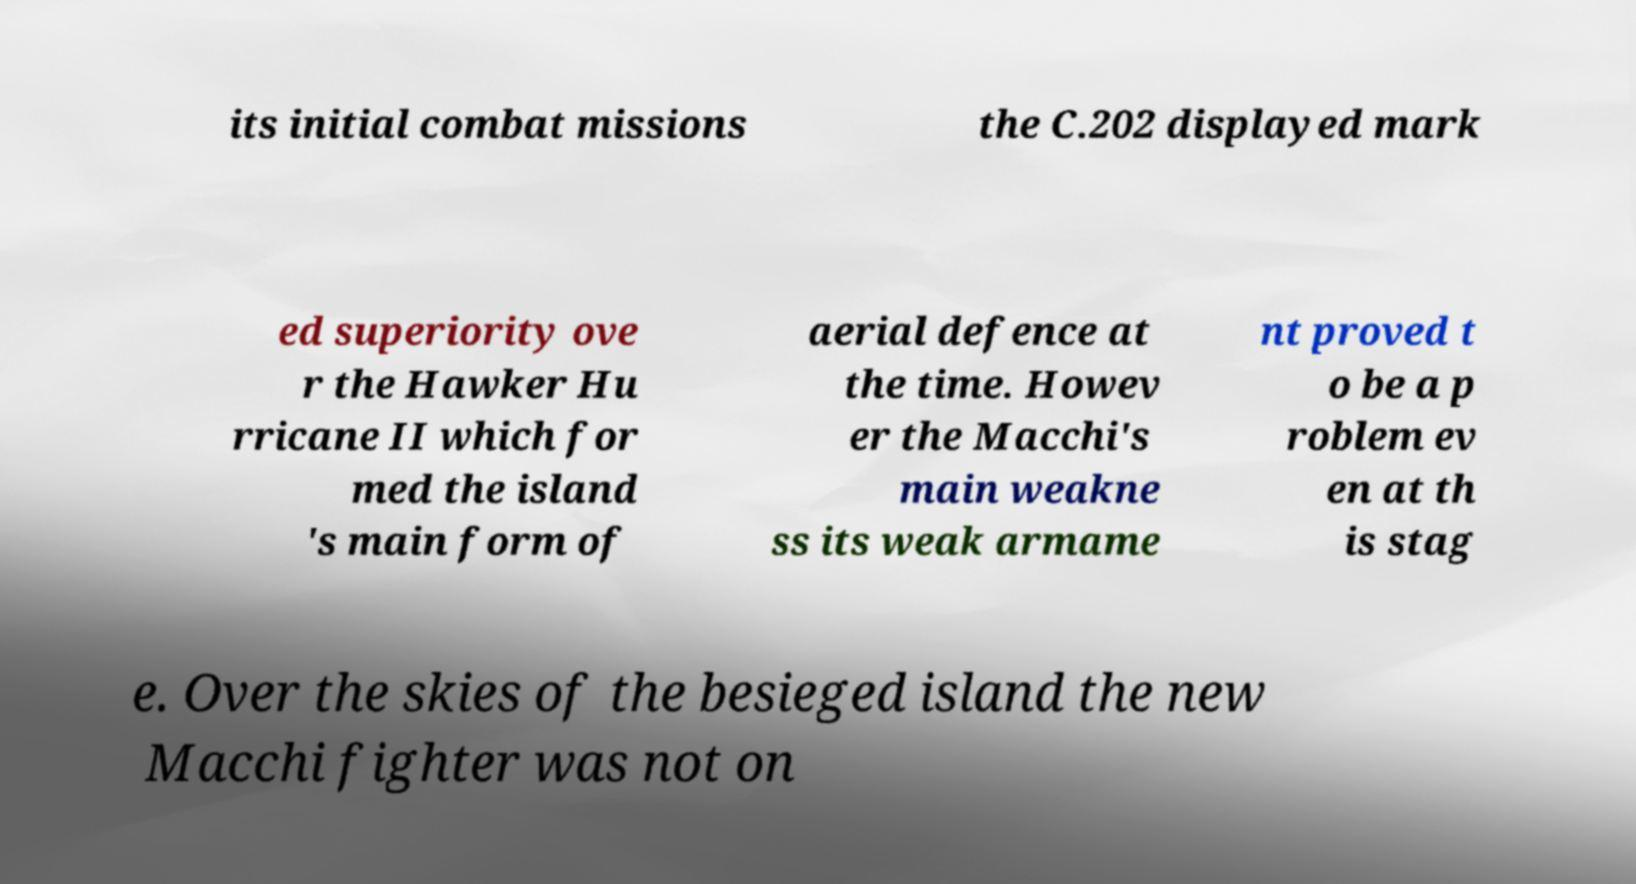Could you extract and type out the text from this image? its initial combat missions the C.202 displayed mark ed superiority ove r the Hawker Hu rricane II which for med the island 's main form of aerial defence at the time. Howev er the Macchi's main weakne ss its weak armame nt proved t o be a p roblem ev en at th is stag e. Over the skies of the besieged island the new Macchi fighter was not on 